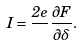<formula> <loc_0><loc_0><loc_500><loc_500>I = \frac { 2 e } { } \frac { \partial F } { \partial \delta } .</formula> 